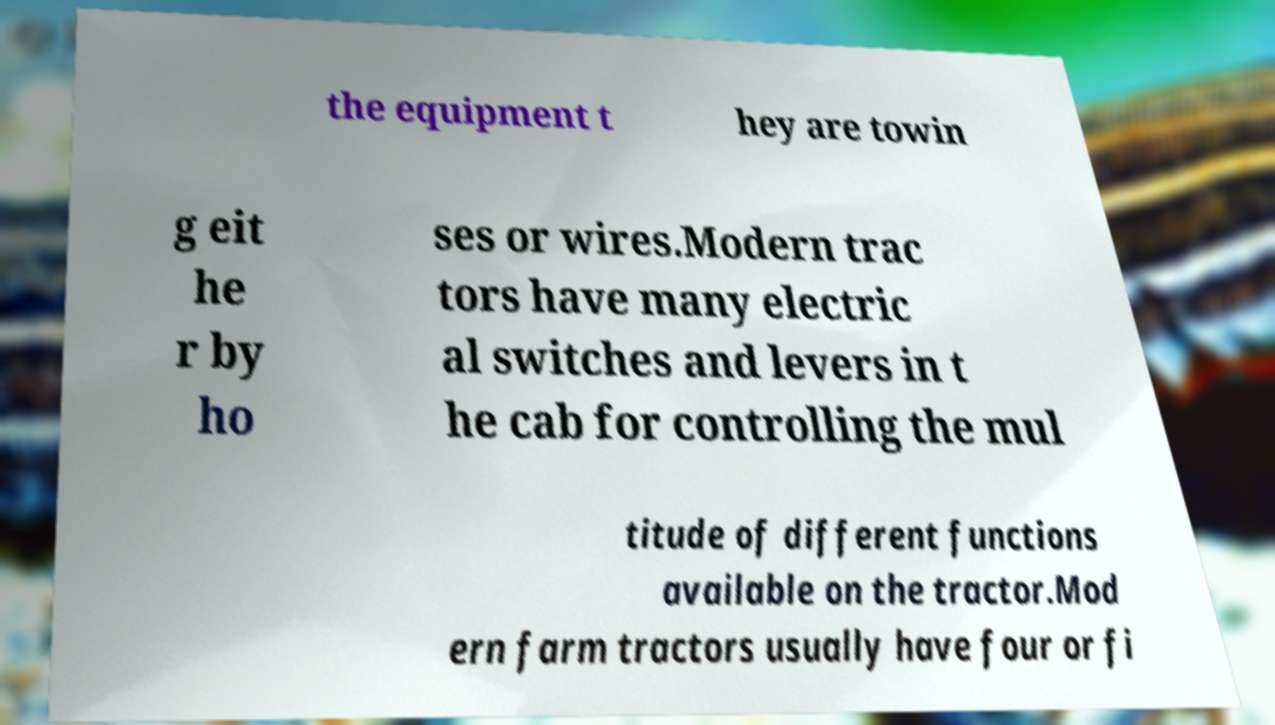Could you extract and type out the text from this image? the equipment t hey are towin g eit he r by ho ses or wires.Modern trac tors have many electric al switches and levers in t he cab for controlling the mul titude of different functions available on the tractor.Mod ern farm tractors usually have four or fi 